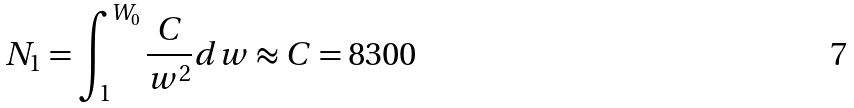<formula> <loc_0><loc_0><loc_500><loc_500>N _ { 1 } = \int _ { 1 } ^ { W _ { 0 } } \frac { C } { w ^ { 2 } } d w \approx C = 8 3 0 0</formula> 